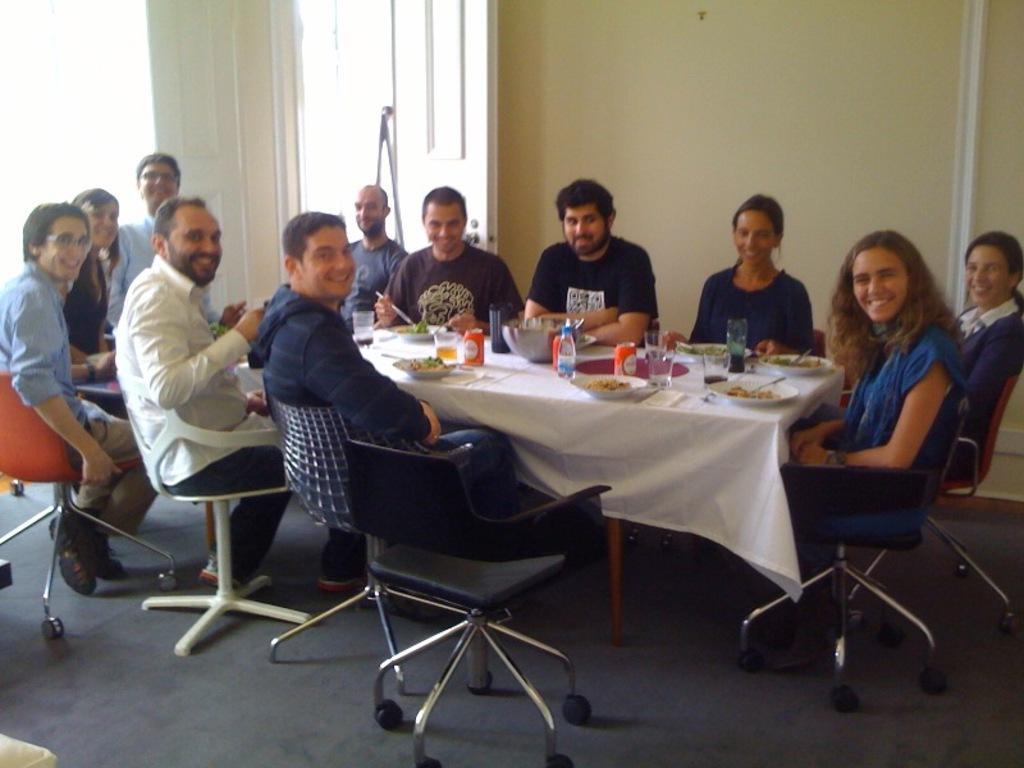In one or two sentences, can you explain what this image depicts? This picture shows a group of people seated on the chairs and we see food bowls water bottles and plates on the table 